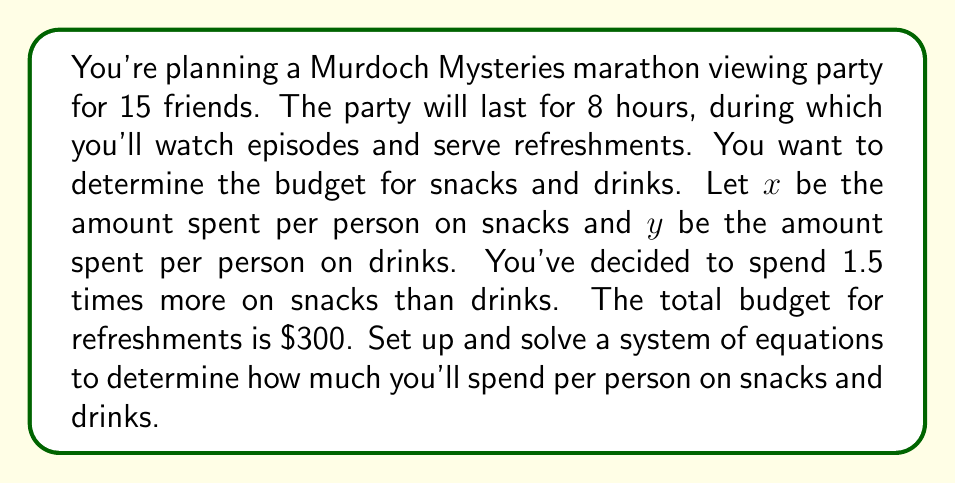Help me with this question. Let's approach this step-by-step:

1) First, let's define our variables:
   $x$ = amount spent per person on snacks
   $y$ = amount spent per person on drinks

2) Now, let's set up our equations based on the given information:

   Equation 1: The total spent on snacks and drinks for 15 people is $300
   $$15x + 15y = 300$$

   Equation 2: The amount spent on snacks is 1.5 times the amount spent on drinks
   $$x = 1.5y$$

3) We now have a system of two equations with two unknowns:
   $$\begin{cases}
   15x + 15y = 300 \\
   x = 1.5y
   \end{cases}$$

4) Let's substitute the second equation into the first:
   $$15(1.5y) + 15y = 300$$

5) Simplify:
   $$22.5y + 15y = 300$$
   $$37.5y = 300$$

6) Solve for $y$:
   $$y = \frac{300}{37.5} = 8$$

7) Now that we know $y$, we can find $x$ using the second equation:
   $$x = 1.5y = 1.5(8) = 12$$

Therefore, you'll spend $12 per person on snacks and $8 per person on drinks.
Answer: $12 per person on snacks, $8 per person on drinks 